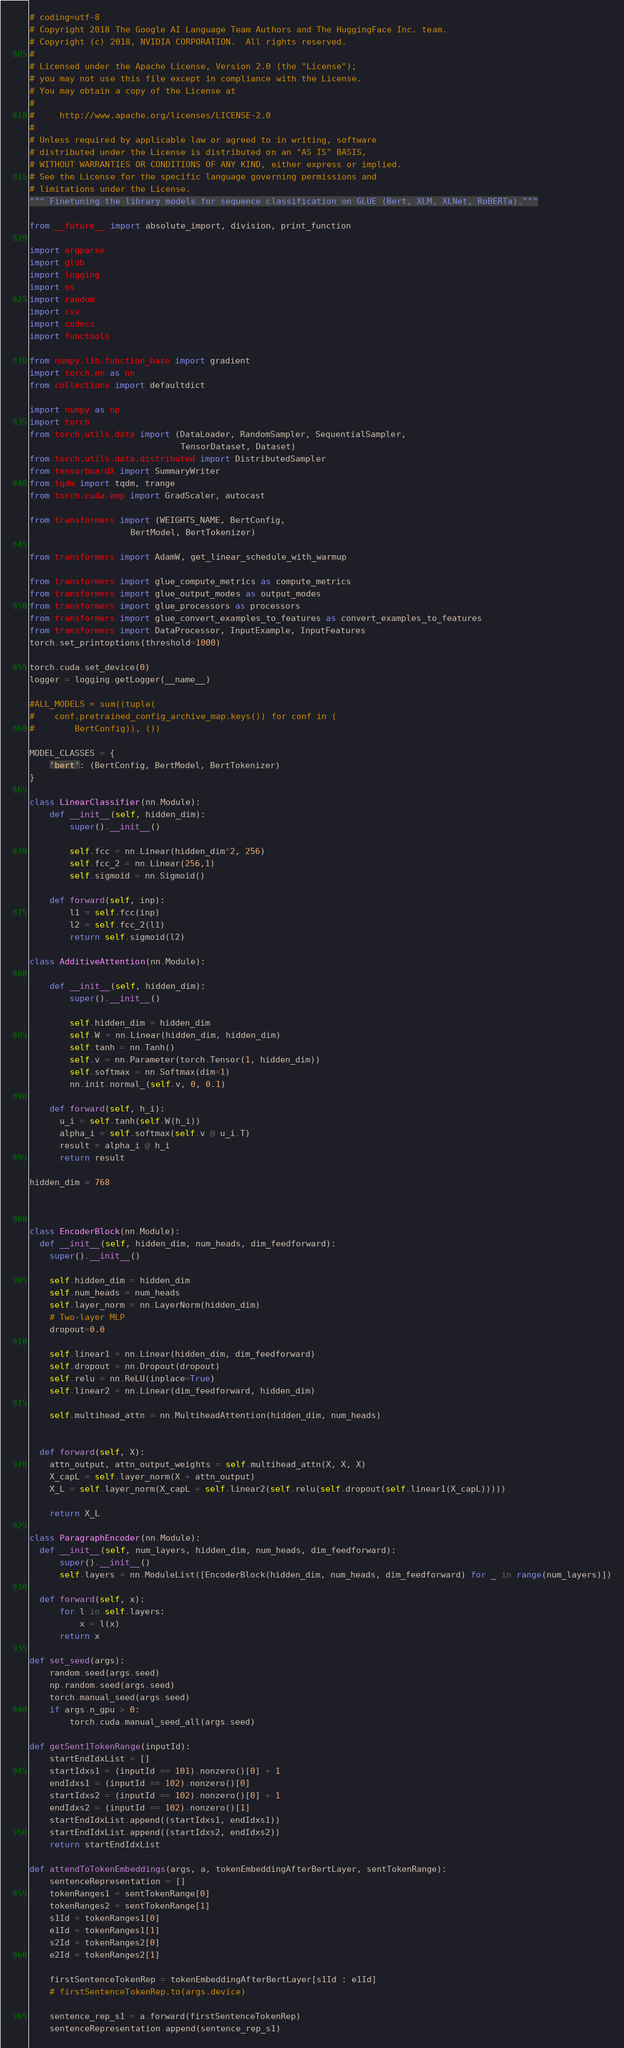<code> <loc_0><loc_0><loc_500><loc_500><_Python_># coding=utf-8
# Copyright 2018 The Google AI Language Team Authors and The HuggingFace Inc. team.
# Copyright (c) 2018, NVIDIA CORPORATION.  All rights reserved.
#
# Licensed under the Apache License, Version 2.0 (the "License");
# you may not use this file except in compliance with the License.
# You may obtain a copy of the License at
#
#     http://www.apache.org/licenses/LICENSE-2.0
#
# Unless required by applicable law or agreed to in writing, software
# distributed under the License is distributed on an "AS IS" BASIS,
# WITHOUT WARRANTIES OR CONDITIONS OF ANY KIND, either express or implied.
# See the License for the specific language governing permissions and
# limitations under the License.
""" Finetuning the library models for sequence classification on GLUE (Bert, XLM, XLNet, RoBERTa)."""

from __future__ import absolute_import, division, print_function

import argparse
import glob
import logging
import os
import random
import csv
import codecs
import functools

from numpy.lib.function_base import gradient
import torch.nn as nn
from collections import defaultdict

import numpy as np
import torch
from torch.utils.data import (DataLoader, RandomSampler, SequentialSampler,
                              TensorDataset, Dataset)
from torch.utils.data.distributed import DistributedSampler
from tensorboardX import SummaryWriter
from tqdm import tqdm, trange
from torch.cuda.amp import GradScaler, autocast

from transformers import (WEIGHTS_NAME, BertConfig,
                    BertModel, BertTokenizer)

from transformers import AdamW, get_linear_schedule_with_warmup

from transformers import glue_compute_metrics as compute_metrics
from transformers import glue_output_modes as output_modes
from transformers import glue_processors as processors
from transformers import glue_convert_examples_to_features as convert_examples_to_features
from transformers import DataProcessor, InputExample, InputFeatures
torch.set_printoptions(threshold=1000)

torch.cuda.set_device(0)
logger = logging.getLogger(__name__)

#ALL_MODELS = sum((tuple(
#    conf.pretrained_config_archive_map.keys()) for conf in (
#        BertConfig)), ())

MODEL_CLASSES = {
    'bert': (BertConfig, BertModel, BertTokenizer)
}

class LinearClassifier(nn.Module):
    def __init__(self, hidden_dim):
        super().__init__()
        
        self.fcc = nn.Linear(hidden_dim*2, 256)
        self.fcc_2 = nn.Linear(256,1)
        self.sigmoid = nn.Sigmoid()

    def forward(self, inp):
        l1 = self.fcc(inp)
        l2 = self.fcc_2(l1)
        return self.sigmoid(l2)

class AdditiveAttention(nn.Module):
    
    def __init__(self, hidden_dim):
        super().__init__()
        
        self.hidden_dim = hidden_dim
        self.W = nn.Linear(hidden_dim, hidden_dim) 
        self.tanh = nn.Tanh()
        self.v = nn.Parameter(torch.Tensor(1, hidden_dim))
        self.softmax = nn.Softmax(dim=1)
        nn.init.normal_(self.v, 0, 0.1)
     
    def forward(self, h_i):
      u_i = self.tanh(self.W(h_i))
      alpha_i = self.softmax(self.v @ u_i.T)
      result = alpha_i @ h_i
      return result

hidden_dim = 768



class EncoderBlock(nn.Module):
  def __init__(self, hidden_dim, num_heads, dim_feedforward):
    super().__init__()
    
    self.hidden_dim = hidden_dim
    self.num_heads = num_heads
    self.layer_norm = nn.LayerNorm(hidden_dim)
    # Two-layer MLP
    dropout=0.0

    self.linear1 = nn.Linear(hidden_dim, dim_feedforward)
    self.dropout = nn.Dropout(dropout)
    self.relu = nn.ReLU(inplace=True)
    self.linear2 = nn.Linear(dim_feedforward, hidden_dim)

    self.multihead_attn = nn.MultiheadAttention(hidden_dim, num_heads)


  def forward(self, X):
    attn_output, attn_output_weights = self.multihead_attn(X, X, X)
    X_capL = self.layer_norm(X + attn_output)
    X_L = self.layer_norm(X_capL + self.linear2(self.relu(self.dropout(self.linear1(X_capL)))))

    return X_L

class ParagraphEncoder(nn.Module):
  def __init__(self, num_layers, hidden_dim, num_heads, dim_feedforward):
      super().__init__()
      self.layers = nn.ModuleList([EncoderBlock(hidden_dim, num_heads, dim_feedforward) for _ in range(num_layers)])

  def forward(self, x):
      for l in self.layers:
          x = l(x)
      return x
    
def set_seed(args):
    random.seed(args.seed)
    np.random.seed(args.seed)
    torch.manual_seed(args.seed)
    if args.n_gpu > 0:
        torch.cuda.manual_seed_all(args.seed)

def getSent1TokenRange(inputId):
    startEndIdxList = []
    startIdxs1 = (inputId == 101).nonzero()[0] + 1
    endIdxs1 = (inputId == 102).nonzero()[0]
    startIdxs2 = (inputId == 102).nonzero()[0] + 1
    endIdxs2 = (inputId == 102).nonzero()[1]
    startEndIdxList.append((startIdxs1, endIdxs1))
    startEndIdxList.append((startIdxs2, endIdxs2))
    return startEndIdxList

def attendToTokenEmbeddings(args, a, tokenEmbeddingAfterBertLayer, sentTokenRange):
    sentenceRepresentation = []
    tokenRanges1 = sentTokenRange[0]
    tokenRanges2 = sentTokenRange[1]
    s1Id = tokenRanges1[0]
    e1Id = tokenRanges1[1]
    s2Id = tokenRanges2[0]
    e2Id = tokenRanges2[1]

    firstSentenceTokenRep = tokenEmbeddingAfterBertLayer[s1Id : e1Id]
    # firstSentenceTokenRep.to(args.device)
    
    sentence_rep_s1 = a.forward(firstSentenceTokenRep)
    sentenceRepresentation.append(sentence_rep_s1)
</code> 